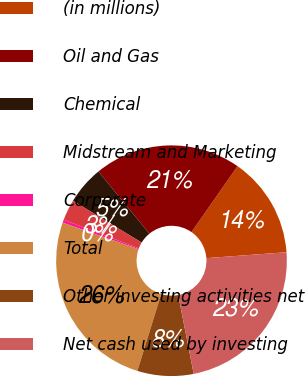<chart> <loc_0><loc_0><loc_500><loc_500><pie_chart><fcel>(in millions)<fcel>Oil and Gas<fcel>Chemical<fcel>Midstream and Marketing<fcel>Corporate<fcel>Total<fcel>Other investing activities net<fcel>Net cash used by investing<nl><fcel>14.12%<fcel>20.62%<fcel>5.39%<fcel>2.91%<fcel>0.43%<fcel>25.57%<fcel>7.86%<fcel>23.09%<nl></chart> 